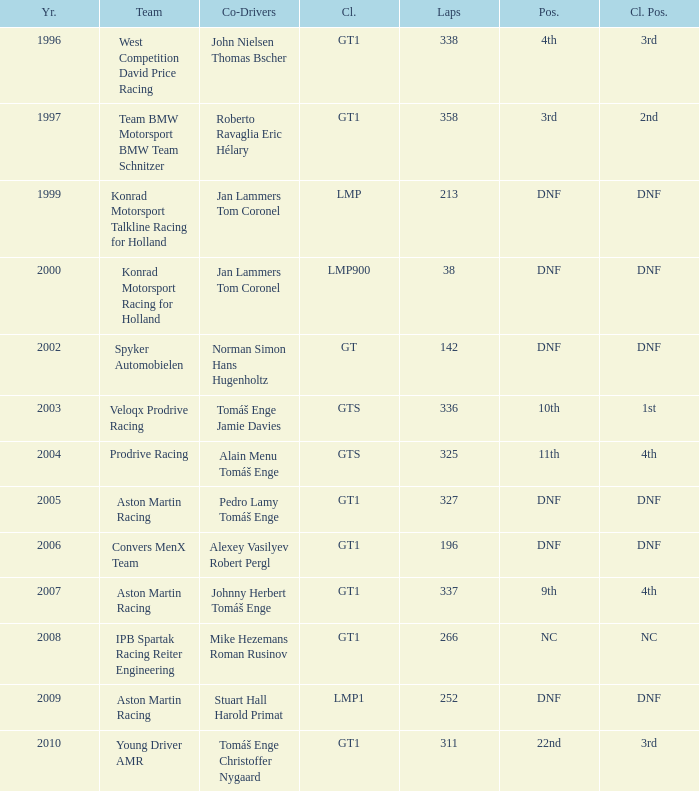Which rank came in 3rd in the group and managed less than 338 laps? 22nd. 